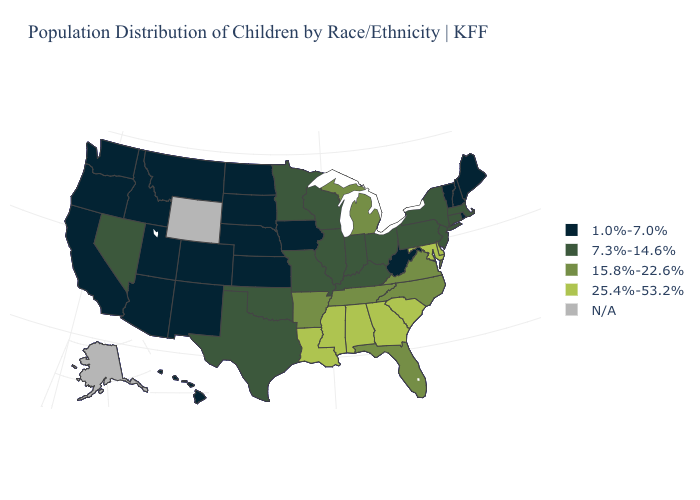Is the legend a continuous bar?
Keep it brief. No. Name the states that have a value in the range 25.4%-53.2%?
Quick response, please. Alabama, Delaware, Georgia, Louisiana, Maryland, Mississippi, South Carolina. Name the states that have a value in the range 15.8%-22.6%?
Answer briefly. Arkansas, Florida, Michigan, North Carolina, Tennessee, Virginia. What is the highest value in states that border Connecticut?
Answer briefly. 7.3%-14.6%. What is the value of Pennsylvania?
Give a very brief answer. 7.3%-14.6%. Does Hawaii have the highest value in the West?
Answer briefly. No. What is the value of Indiana?
Concise answer only. 7.3%-14.6%. What is the value of Indiana?
Answer briefly. 7.3%-14.6%. What is the highest value in the Northeast ?
Answer briefly. 7.3%-14.6%. Does Nevada have the highest value in the West?
Write a very short answer. Yes. What is the value of Mississippi?
Answer briefly. 25.4%-53.2%. Which states have the lowest value in the West?
Short answer required. Arizona, California, Colorado, Hawaii, Idaho, Montana, New Mexico, Oregon, Utah, Washington. Name the states that have a value in the range 1.0%-7.0%?
Write a very short answer. Arizona, California, Colorado, Hawaii, Idaho, Iowa, Kansas, Maine, Montana, Nebraska, New Hampshire, New Mexico, North Dakota, Oregon, Rhode Island, South Dakota, Utah, Vermont, Washington, West Virginia. Is the legend a continuous bar?
Be succinct. No. 